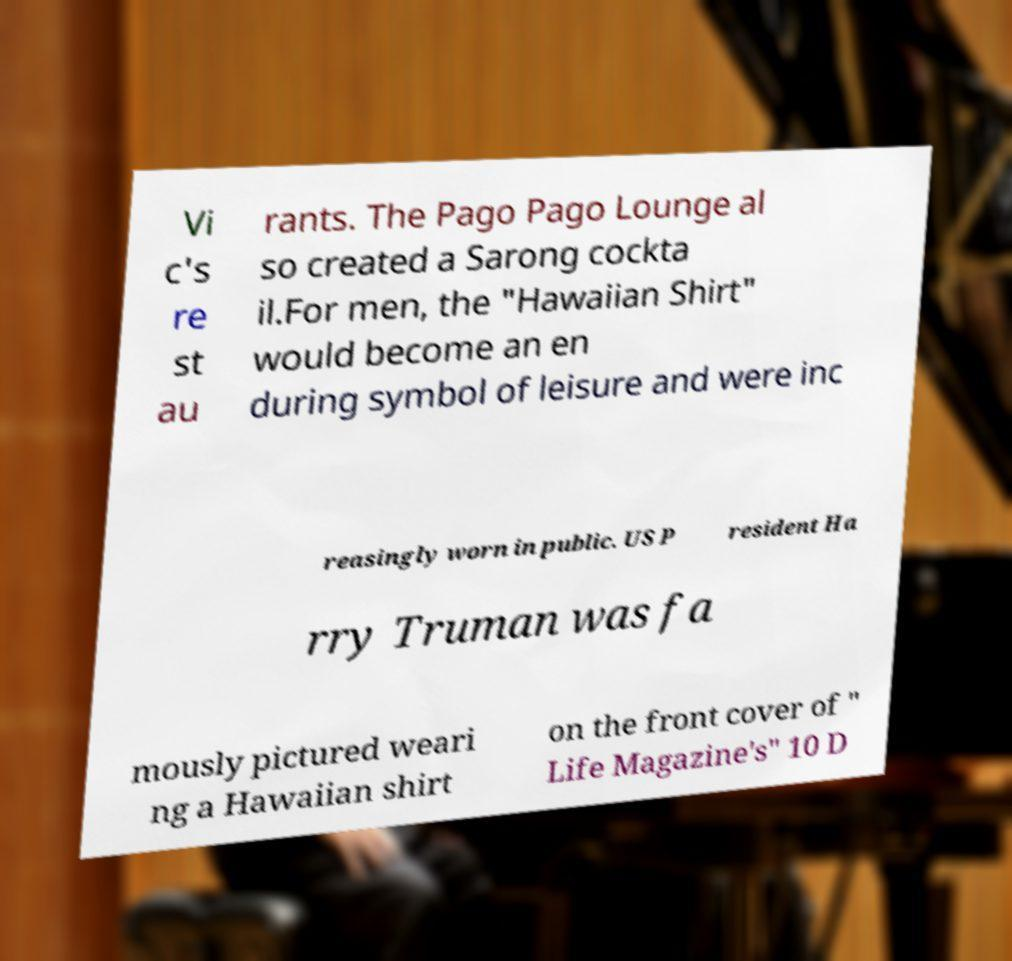What messages or text are displayed in this image? I need them in a readable, typed format. Vi c's re st au rants. The Pago Pago Lounge al so created a Sarong cockta il.For men, the "Hawaiian Shirt" would become an en during symbol of leisure and were inc reasingly worn in public. US P resident Ha rry Truman was fa mously pictured weari ng a Hawaiian shirt on the front cover of " Life Magazine's" 10 D 